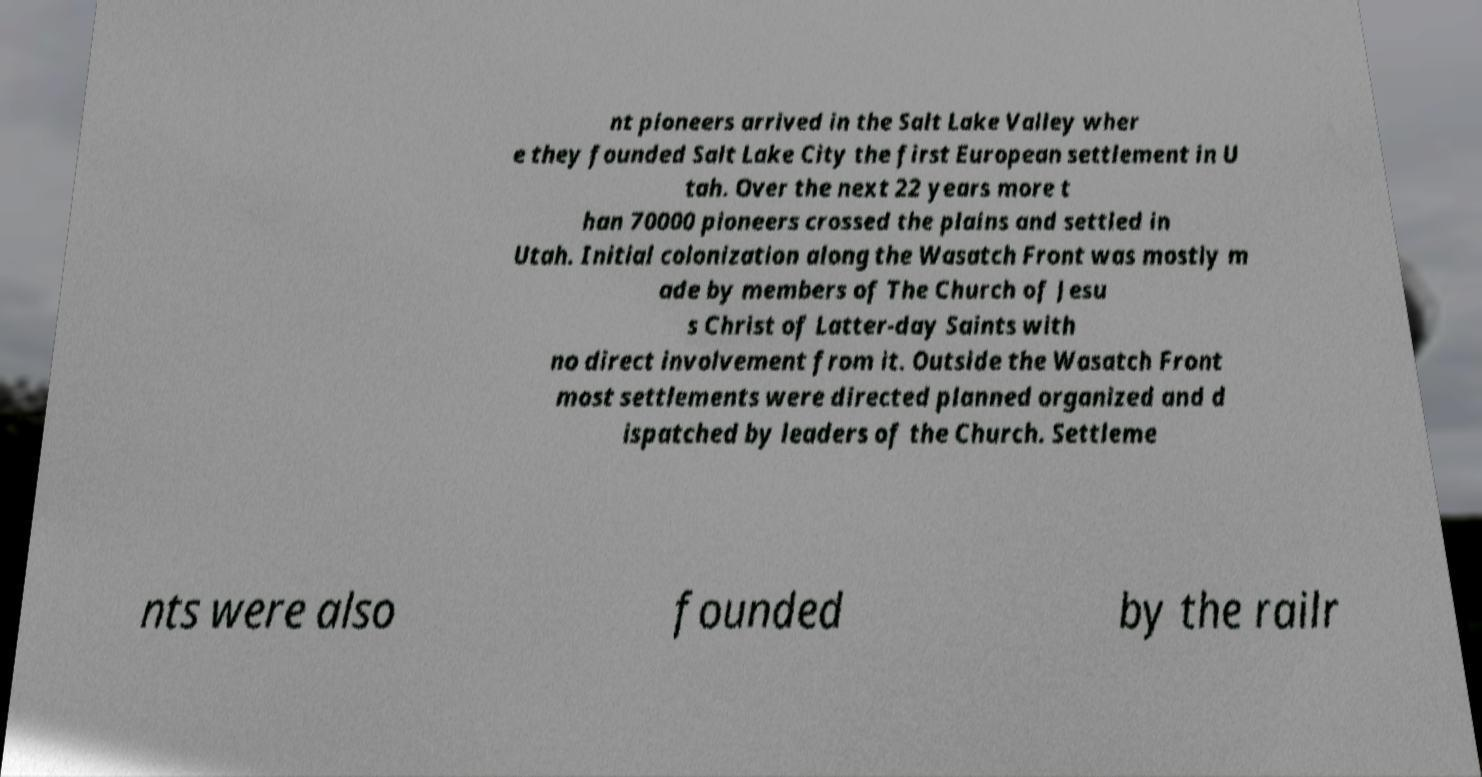Could you extract and type out the text from this image? nt pioneers arrived in the Salt Lake Valley wher e they founded Salt Lake City the first European settlement in U tah. Over the next 22 years more t han 70000 pioneers crossed the plains and settled in Utah. Initial colonization along the Wasatch Front was mostly m ade by members of The Church of Jesu s Christ of Latter-day Saints with no direct involvement from it. Outside the Wasatch Front most settlements were directed planned organized and d ispatched by leaders of the Church. Settleme nts were also founded by the railr 